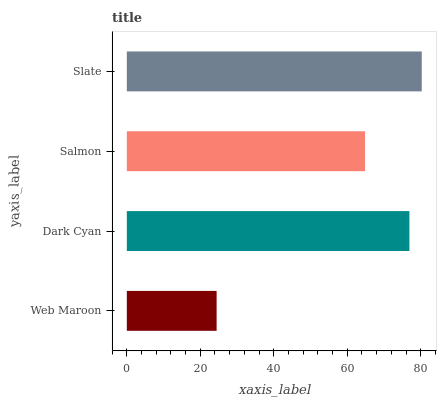Is Web Maroon the minimum?
Answer yes or no. Yes. Is Slate the maximum?
Answer yes or no. Yes. Is Dark Cyan the minimum?
Answer yes or no. No. Is Dark Cyan the maximum?
Answer yes or no. No. Is Dark Cyan greater than Web Maroon?
Answer yes or no. Yes. Is Web Maroon less than Dark Cyan?
Answer yes or no. Yes. Is Web Maroon greater than Dark Cyan?
Answer yes or no. No. Is Dark Cyan less than Web Maroon?
Answer yes or no. No. Is Dark Cyan the high median?
Answer yes or no. Yes. Is Salmon the low median?
Answer yes or no. Yes. Is Web Maroon the high median?
Answer yes or no. No. Is Slate the low median?
Answer yes or no. No. 